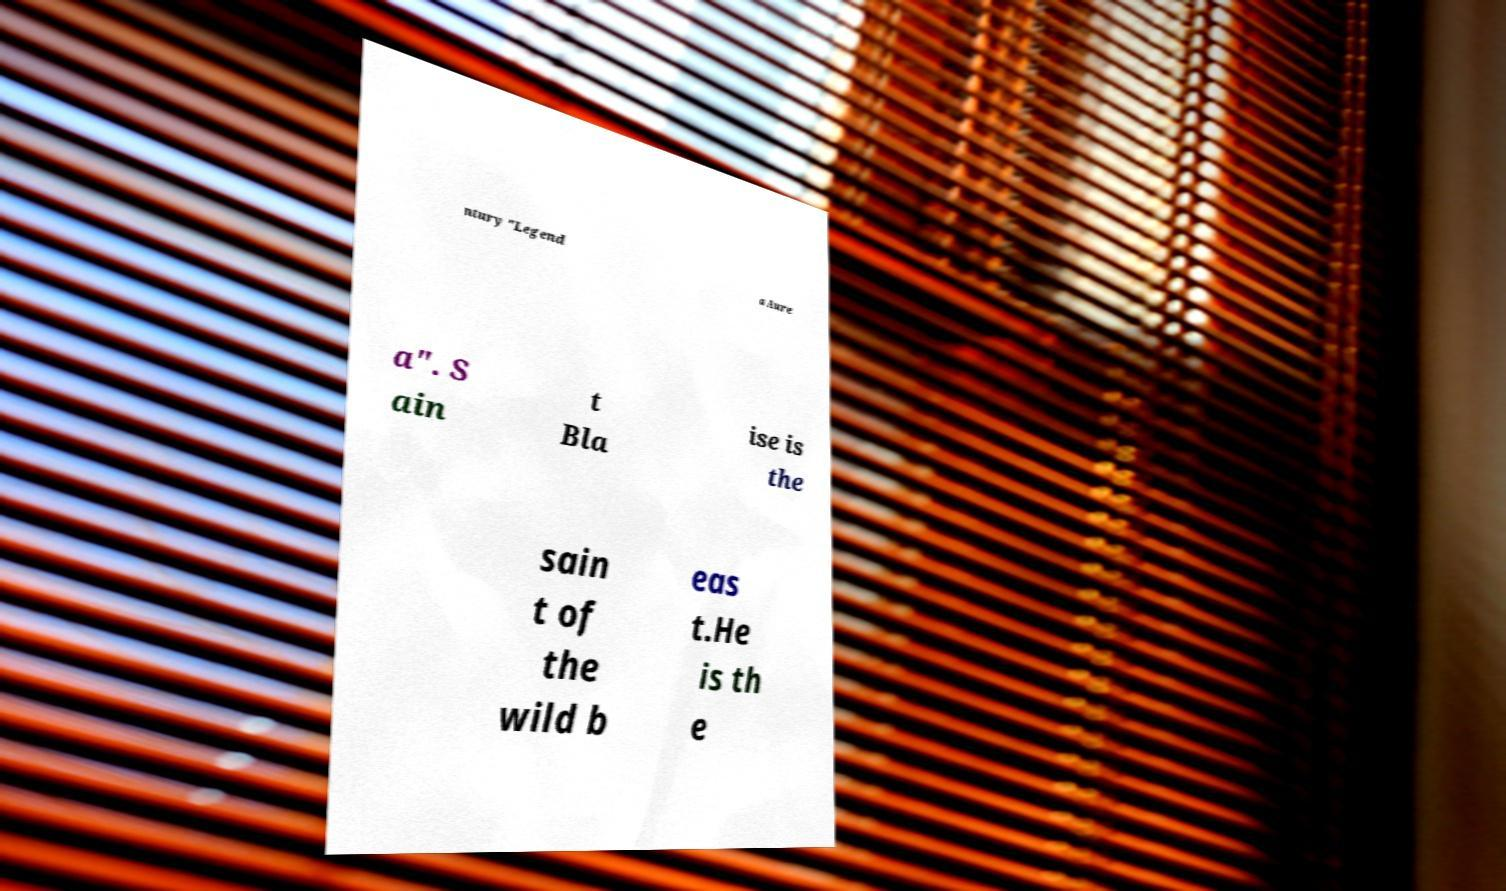For documentation purposes, I need the text within this image transcribed. Could you provide that? ntury "Legend a Aure a". S ain t Bla ise is the sain t of the wild b eas t.He is th e 